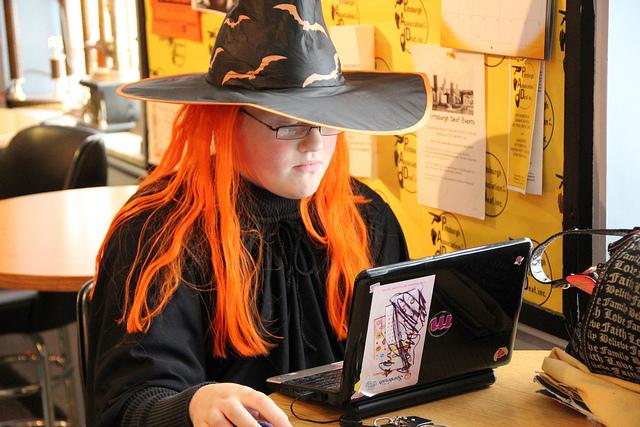Is she a witch?
Short answer required. Yes. What color is her hair?
Be succinct. Orange. What is she looking at?
Concise answer only. Laptop. 